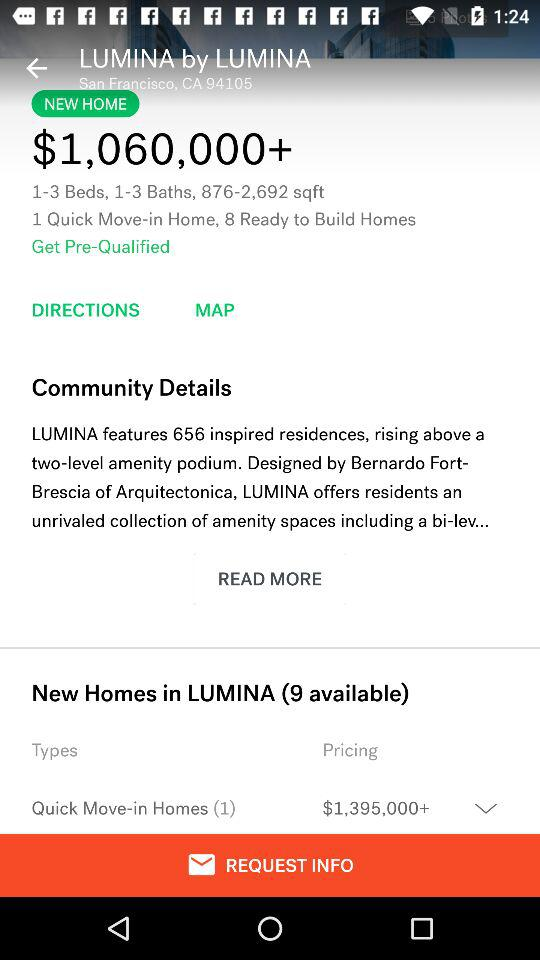How many beds are there in the "Lumina" home by "Lumina"? There are 1-3 beds in the "Lumina" home by "Lumina". 